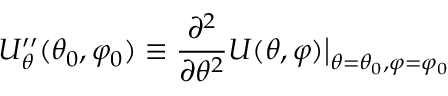Convert formula to latex. <formula><loc_0><loc_0><loc_500><loc_500>U _ { \theta } ^ { \prime \prime } ( \theta _ { 0 } , \varphi _ { 0 } ) \equiv \frac { \partial ^ { 2 } } { \partial \theta ^ { 2 } } U ( \theta , \varphi ) \Big | _ { \theta = \theta _ { 0 } , \varphi = \varphi _ { 0 } }</formula> 